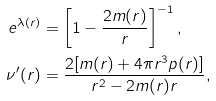Convert formula to latex. <formula><loc_0><loc_0><loc_500><loc_500>e ^ { \lambda ( r ) } & = \left [ 1 - \frac { 2 m ( r ) } { r } \right ] ^ { - 1 } , \\ \nu ^ { \prime } ( r ) & = \frac { 2 [ m ( r ) + 4 \pi r ^ { 3 } p ( r ) ] } { r ^ { 2 } - 2 m ( r ) r } ,</formula> 